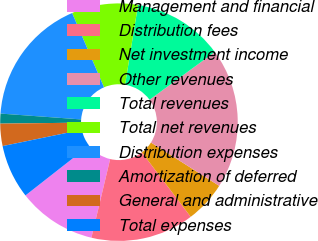Convert chart. <chart><loc_0><loc_0><loc_500><loc_500><pie_chart><fcel>Management and financial<fcel>Distribution fees<fcel>Net investment income<fcel>Other revenues<fcel>Total revenues<fcel>Total net revenues<fcel>Distribution expenses<fcel>Amortization of deferred<fcel>General and administrative<fcel>Total expenses<nl><fcel>10.7%<fcel>14.05%<fcel>5.67%<fcel>19.07%<fcel>12.37%<fcel>9.02%<fcel>17.4%<fcel>1.35%<fcel>3.03%<fcel>7.35%<nl></chart> 